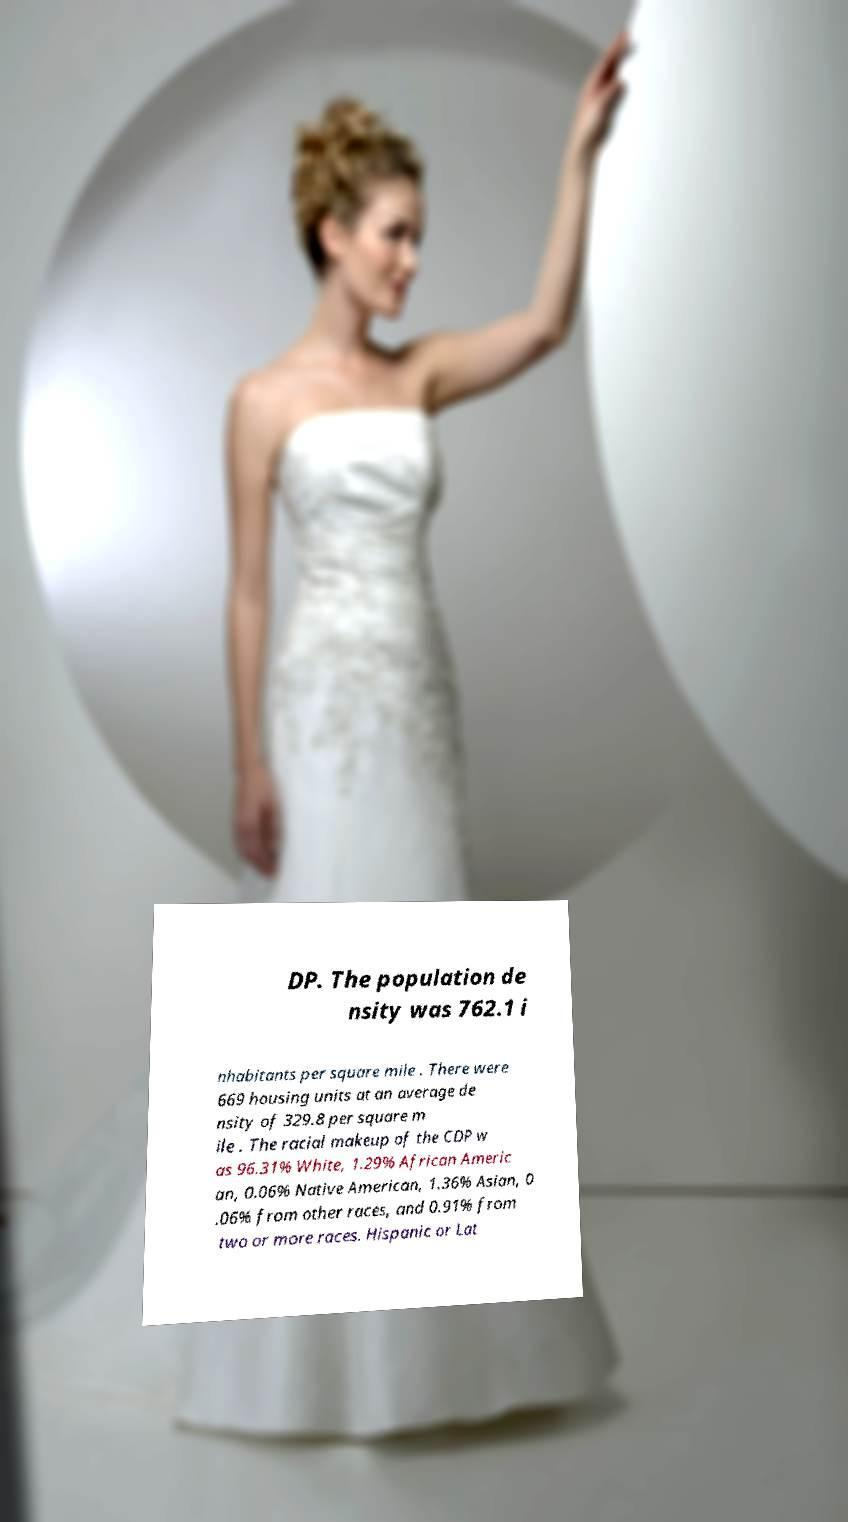Please read and relay the text visible in this image. What does it say? DP. The population de nsity was 762.1 i nhabitants per square mile . There were 669 housing units at an average de nsity of 329.8 per square m ile . The racial makeup of the CDP w as 96.31% White, 1.29% African Americ an, 0.06% Native American, 1.36% Asian, 0 .06% from other races, and 0.91% from two or more races. Hispanic or Lat 